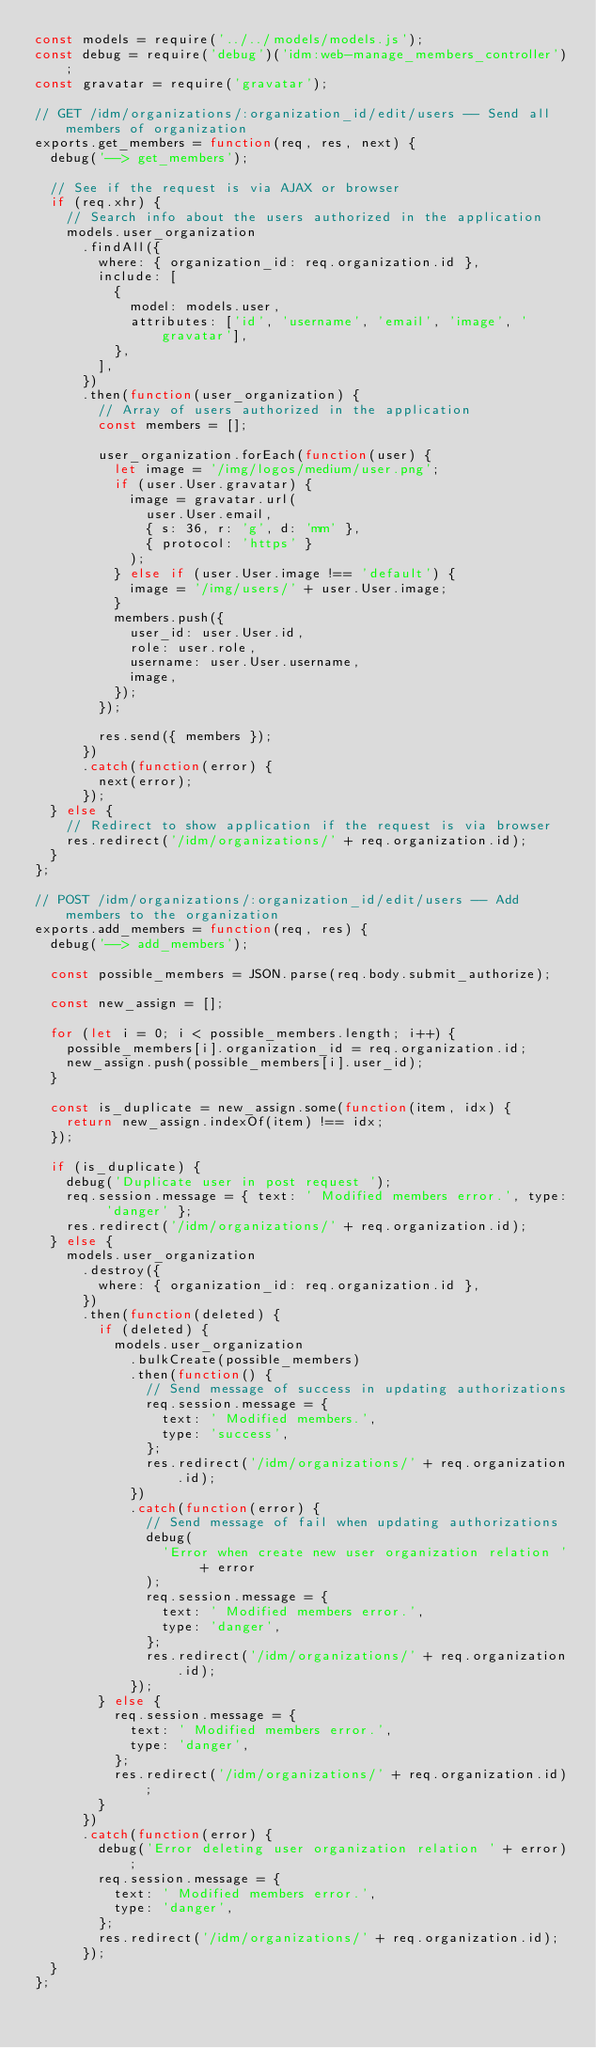Convert code to text. <code><loc_0><loc_0><loc_500><loc_500><_JavaScript_>const models = require('../../models/models.js');
const debug = require('debug')('idm:web-manage_members_controller');
const gravatar = require('gravatar');

// GET /idm/organizations/:organization_id/edit/users -- Send all members of organization
exports.get_members = function(req, res, next) {
  debug('--> get_members');

  // See if the request is via AJAX or browser
  if (req.xhr) {
    // Search info about the users authorized in the application
    models.user_organization
      .findAll({
        where: { organization_id: req.organization.id },
        include: [
          {
            model: models.user,
            attributes: ['id', 'username', 'email', 'image', 'gravatar'],
          },
        ],
      })
      .then(function(user_organization) {
        // Array of users authorized in the application
        const members = [];

        user_organization.forEach(function(user) {
          let image = '/img/logos/medium/user.png';
          if (user.User.gravatar) {
            image = gravatar.url(
              user.User.email,
              { s: 36, r: 'g', d: 'mm' },
              { protocol: 'https' }
            );
          } else if (user.User.image !== 'default') {
            image = '/img/users/' + user.User.image;
          }
          members.push({
            user_id: user.User.id,
            role: user.role,
            username: user.User.username,
            image,
          });
        });

        res.send({ members });
      })
      .catch(function(error) {
        next(error);
      });
  } else {
    // Redirect to show application if the request is via browser
    res.redirect('/idm/organizations/' + req.organization.id);
  }
};

// POST /idm/organizations/:organization_id/edit/users -- Add members to the organization
exports.add_members = function(req, res) {
  debug('--> add_members');

  const possible_members = JSON.parse(req.body.submit_authorize);

  const new_assign = [];

  for (let i = 0; i < possible_members.length; i++) {
    possible_members[i].organization_id = req.organization.id;
    new_assign.push(possible_members[i].user_id);
  }

  const is_duplicate = new_assign.some(function(item, idx) {
    return new_assign.indexOf(item) !== idx;
  });

  if (is_duplicate) {
    debug('Duplicate user in post request ');
    req.session.message = { text: ' Modified members error.', type: 'danger' };
    res.redirect('/idm/organizations/' + req.organization.id);
  } else {
    models.user_organization
      .destroy({
        where: { organization_id: req.organization.id },
      })
      .then(function(deleted) {
        if (deleted) {
          models.user_organization
            .bulkCreate(possible_members)
            .then(function() {
              // Send message of success in updating authorizations
              req.session.message = {
                text: ' Modified members.',
                type: 'success',
              };
              res.redirect('/idm/organizations/' + req.organization.id);
            })
            .catch(function(error) {
              // Send message of fail when updating authorizations
              debug(
                'Error when create new user organization relation ' + error
              );
              req.session.message = {
                text: ' Modified members error.',
                type: 'danger',
              };
              res.redirect('/idm/organizations/' + req.organization.id);
            });
        } else {
          req.session.message = {
            text: ' Modified members error.',
            type: 'danger',
          };
          res.redirect('/idm/organizations/' + req.organization.id);
        }
      })
      .catch(function(error) {
        debug('Error deleting user organization relation ' + error);
        req.session.message = {
          text: ' Modified members error.',
          type: 'danger',
        };
        res.redirect('/idm/organizations/' + req.organization.id);
      });
  }
};
</code> 